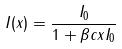Convert formula to latex. <formula><loc_0><loc_0><loc_500><loc_500>I ( x ) = \frac { I _ { 0 } } { 1 + \beta c x I _ { 0 } }</formula> 